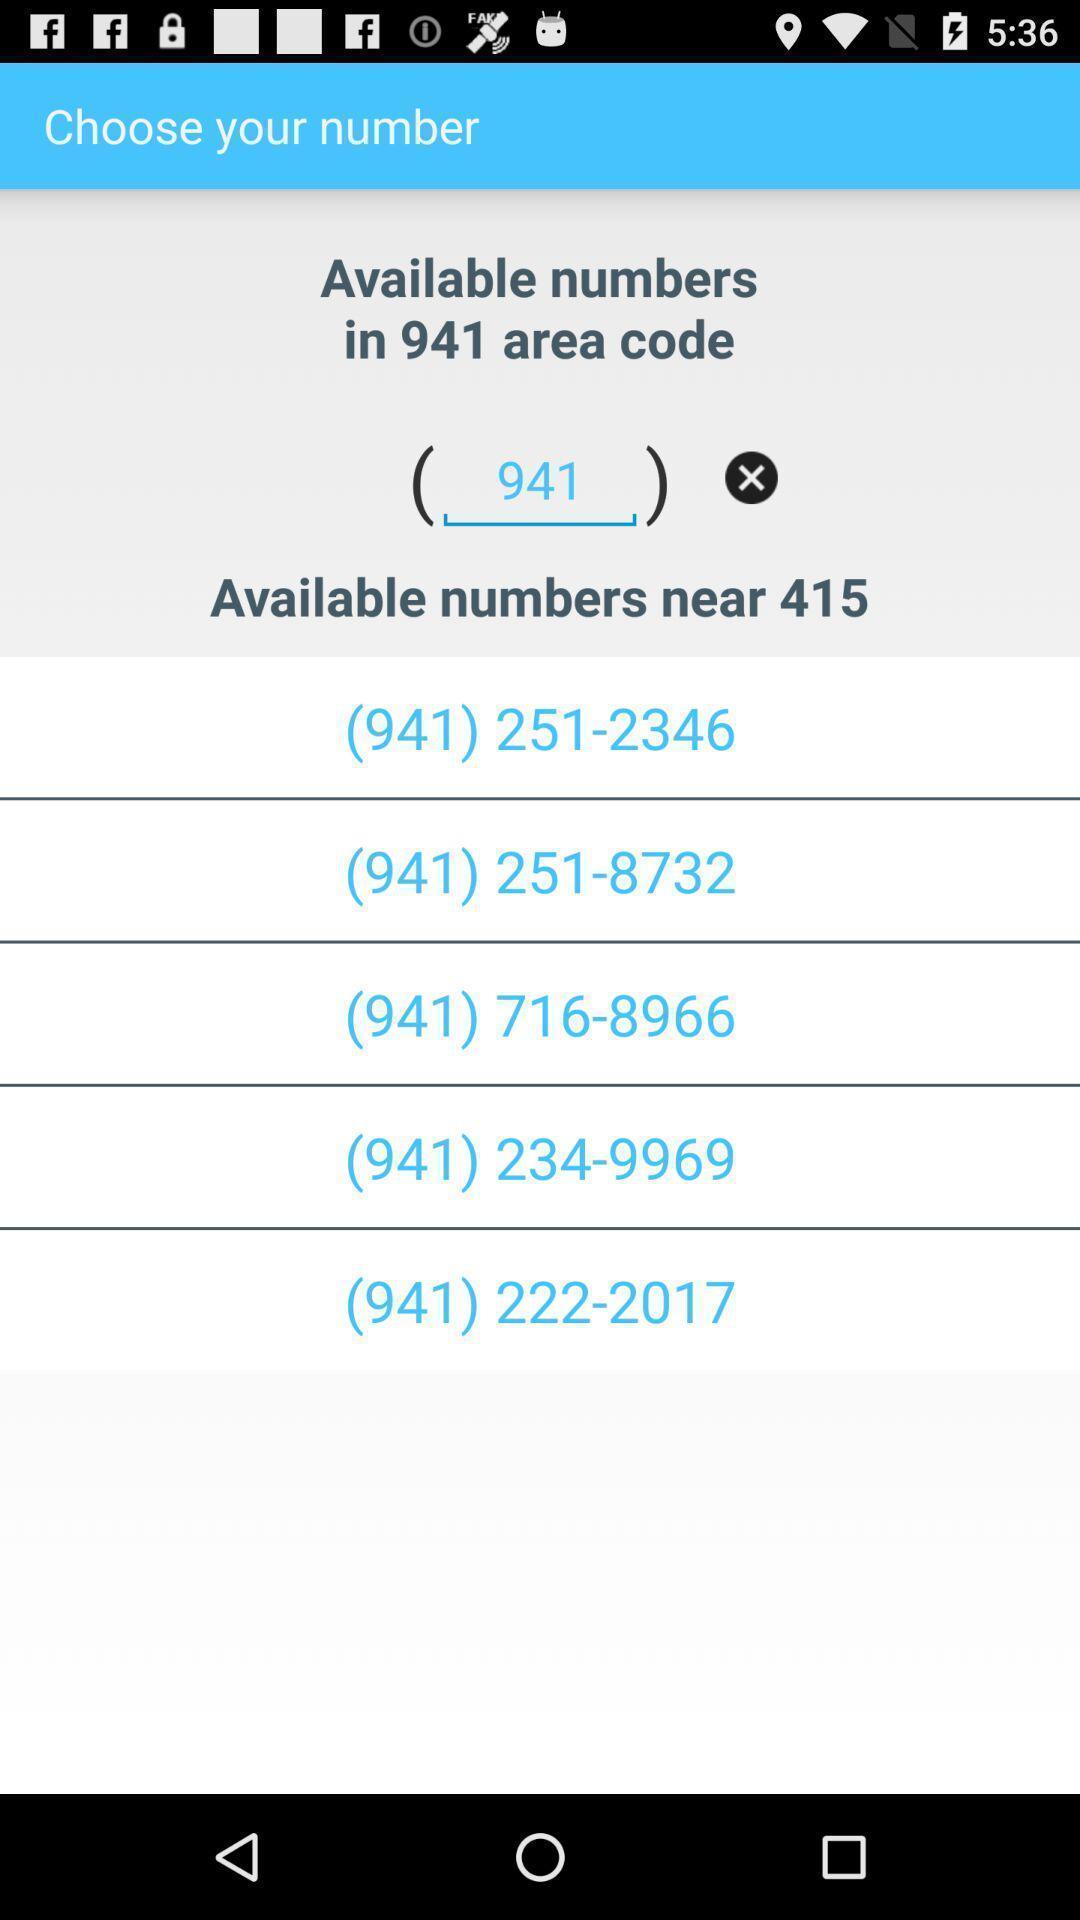Tell me about the visual elements in this screen capture. Page showing list of different numbers. 